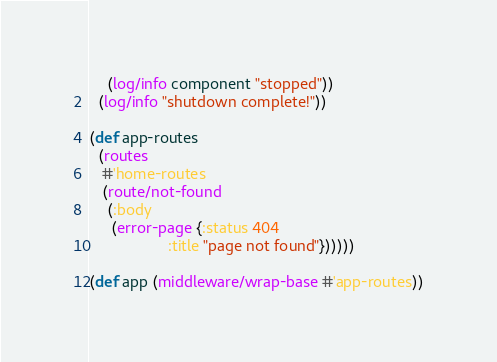<code> <loc_0><loc_0><loc_500><loc_500><_Clojure_>    (log/info component "stopped"))
  (log/info "shutdown complete!"))

(def app-routes
  (routes
   #'home-routes
   (route/not-found
    (:body
     (error-page {:status 404
                  :title "page not found"})))))

(def app (middleware/wrap-base #'app-routes))
</code> 